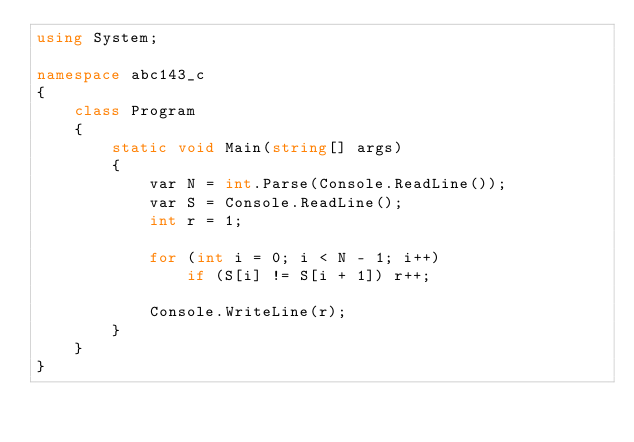<code> <loc_0><loc_0><loc_500><loc_500><_C#_>using System;

namespace abc143_c
{
    class Program
    {
        static void Main(string[] args)
        {
            var N = int.Parse(Console.ReadLine());
            var S = Console.ReadLine();
            int r = 1;

            for (int i = 0; i < N - 1; i++)
                if (S[i] != S[i + 1]) r++;

            Console.WriteLine(r);
        }
    }
}
</code> 